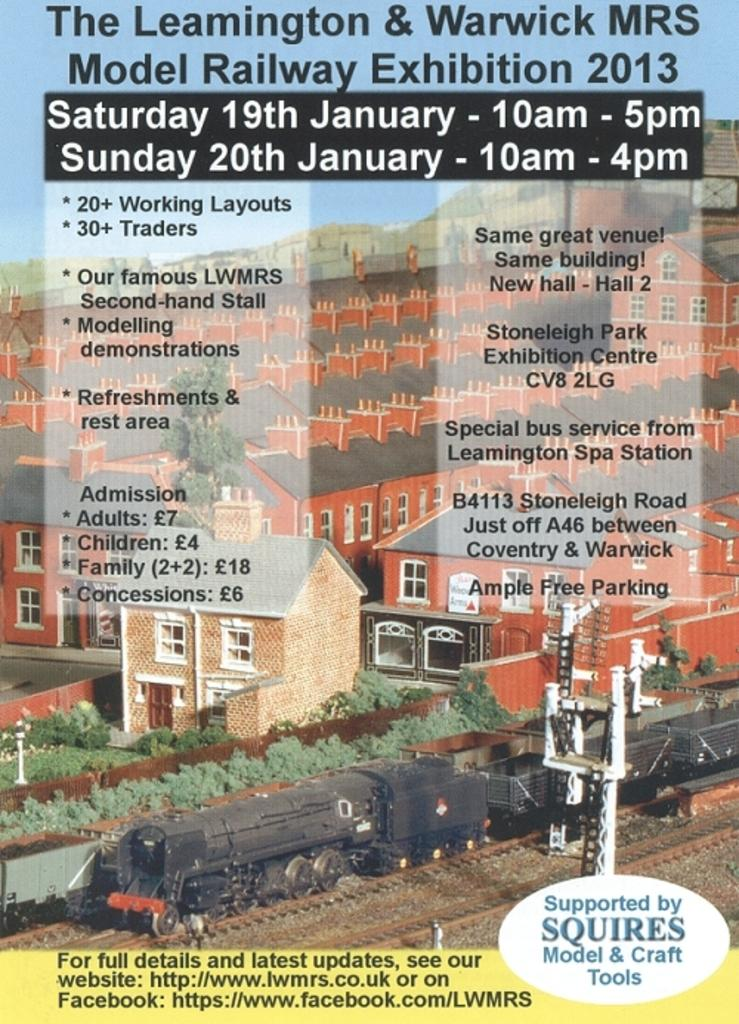<image>
Render a clear and concise summary of the photo. Poster that shows buildings and says it is supported by Squires. 